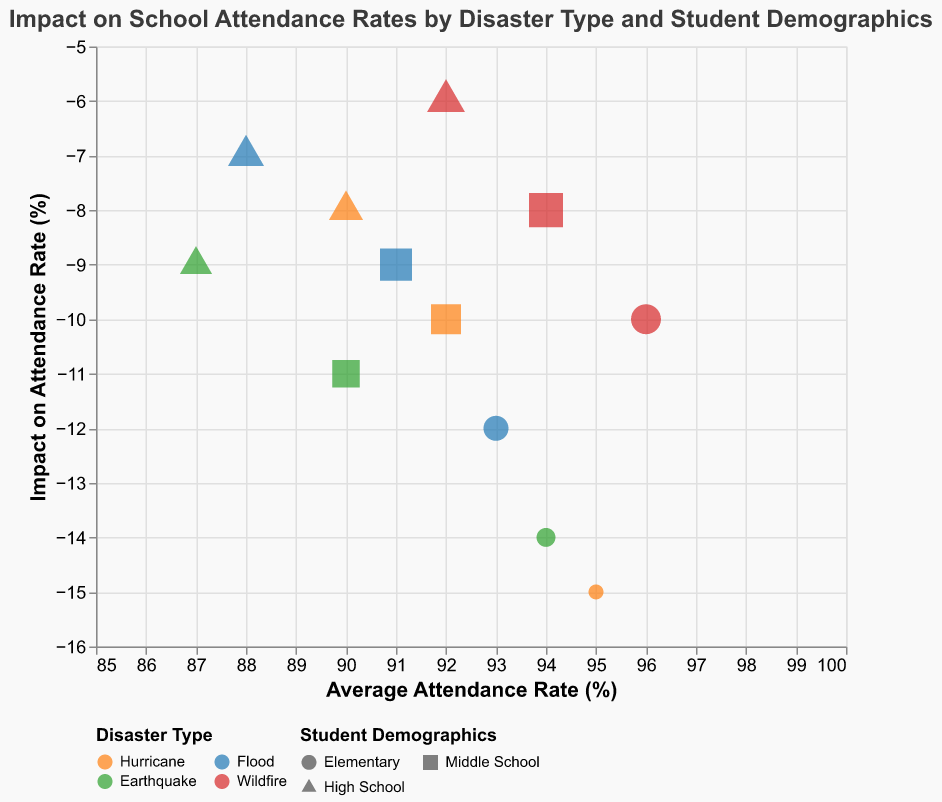What is the title of the figure? The title of the figure is displayed at the top, and it directly provides the name of the chart.
Answer: Impact on School Attendance Rates by Disaster Type and Student Demographics Which student demographic has the highest average attendance rate for Wildfires? To find this, look for the Wildfire data points and identify the one with the highest average attendance rate.
Answer: Elementary What is the impact on attendance rate for Middle School students affected by Floods? Locate data points related to Floods and Middle School students, then observe the impact on attendance rate.
Answer: -9% How does the impact on attendance rate for High School students compare between Earthquakes and Hurricanes? Identify data points for Earthquakes and Hurricanes for High School students, and compare their impact on attendance rates. Earthquake has -9 and Hurricane has -8.
Answer: Earthquake: -9% vs. Hurricane: -8% Which disaster type has the most significant impact on Elementary school attendance rates? Look at the Elementary school data points and compare the impact on attendance rate for each disaster type. The Hurricane has the most significant impact with -15%.
Answer: Hurricane What is the average attendance rate for Middle School students affected by Earthquakes? Locate the data point for Earthquake and Middle School, and observe the average attendance rate.
Answer: 90% Which disaster type causes the least impact on attendance rates for High School students? Examine the High School data points and compare the impact on attendance rates. Wildfire has the least impact with -6%.
Answer: Wildfire Calculate the total impact on attendance rates for all student demographics affected by Floods. Sum up the impact on attendance rates for Elementary, Middle, and High School students affected by Floods (-12 + -9 + -7) = -28.
Answer: -28 Explain the trend in impact on attendance rates for Elementary, Middle, and High School students across various disaster types. Generally, for each disaster type, the impact on attendance decreases as the school level increases. For instance, in Hurricanes: Elementary (-15), Middle School (-10), and High School (-8); similarly for other disaster types.
Answer: Decreasing impact with higher school levels 